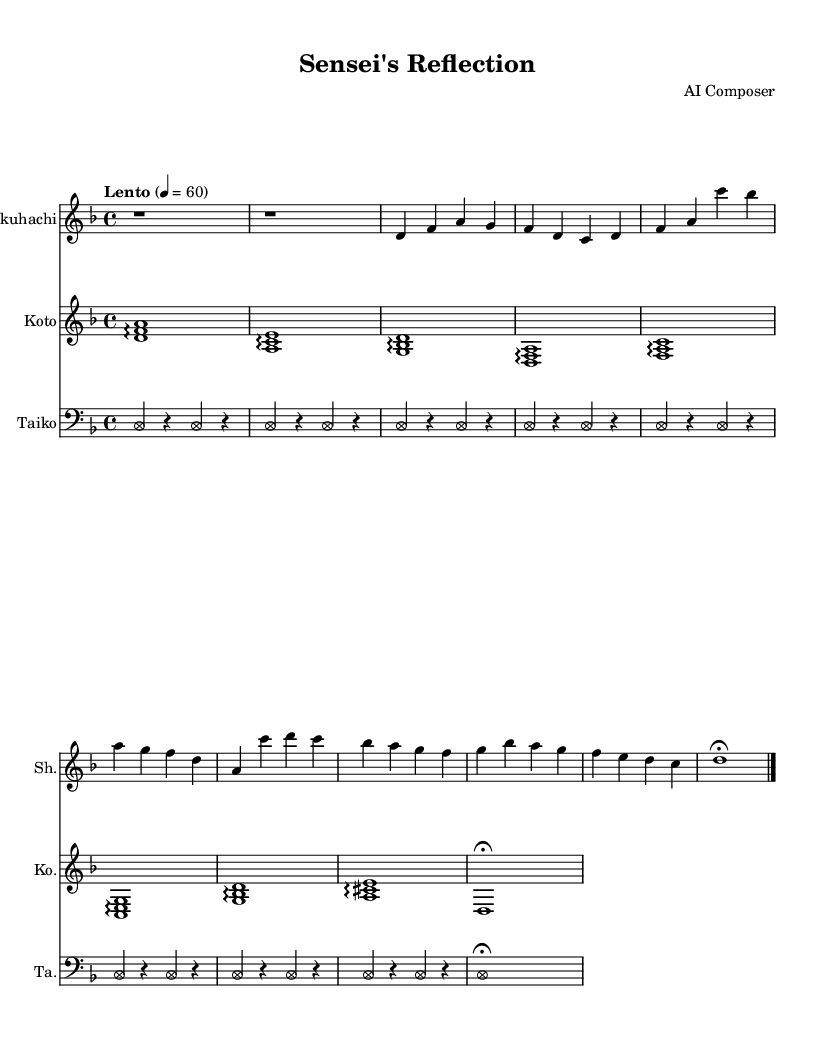What is the key signature of this music? The key signature is D minor, which has one flat (B flat). This can be determined by looking at the beginning of the score where the key signature is notated.
Answer: D minor What is the time signature of this music? The time signature is shown at the beginning of the score as 4/4, indicating that there are four beats per measure and the quarter note gets one beat.
Answer: 4/4 What tempo marking is given in this piece? The tempo marking is "Lento", which indicates a slow tempo. This is visible in the score, placed above the staff.
Answer: Lento How many measures are in the shakuhachi part? The shakuhachi part consists of 8 measures, which can be counted by identifying the bar lines in the shakuhachi staff.
Answer: 8 Which instrument plays the lowest notes? The taiko plays the lowest notes, as indicated by the bass clef used in its staff, which is characteristic for lower pitch instruments.
Answer: Taiko What type of musical notation is used for the taiko? The taiko part uses note heads styled as circles (xcircle), which indicates a unique notation for the rhythms that taiko drums typically produce. This is an intentional design feature shown in the part.
Answer: xcircle Which instrument is primarily responsible for harmony in this piece? The koto is responsible for harmony, as it plays arpeggiated chords that provide harmonic support throughout the piece. This is seen in the koto staff where it plays multiple pitches together.
Answer: Koto 